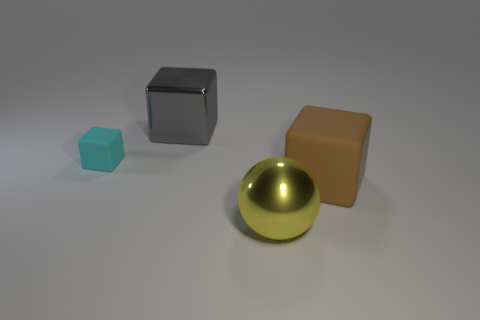Add 1 big brown blocks. How many objects exist? 5 Subtract all large gray shiny blocks. How many blocks are left? 2 Subtract all gray blocks. How many blocks are left? 2 Subtract all red spheres. How many yellow blocks are left? 0 Subtract all balls. How many objects are left? 3 Subtract 2 cubes. How many cubes are left? 1 Subtract all cyan blocks. Subtract all gray cylinders. How many blocks are left? 2 Subtract all big green metal blocks. Subtract all brown blocks. How many objects are left? 3 Add 4 brown matte cubes. How many brown matte cubes are left? 5 Add 1 purple matte cylinders. How many purple matte cylinders exist? 1 